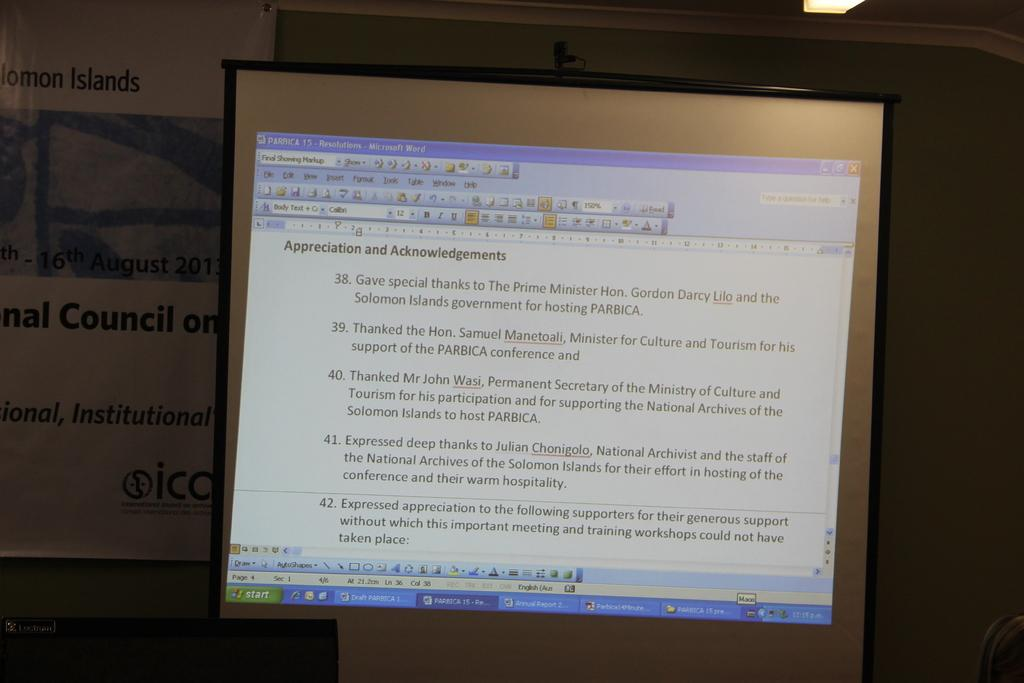<image>
Write a terse but informative summary of the picture. COmputer monitor which talks about the Appreciation and Acknowledgements. 